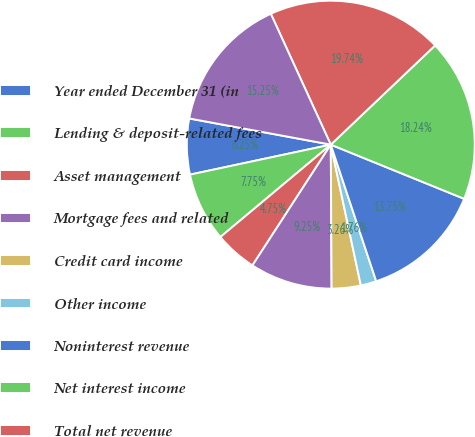Convert chart to OTSL. <chart><loc_0><loc_0><loc_500><loc_500><pie_chart><fcel>Year ended December 31 (in<fcel>Lending & deposit-related fees<fcel>Asset management<fcel>Mortgage fees and related<fcel>Credit card income<fcel>Other income<fcel>Noninterest revenue<fcel>Net interest income<fcel>Total net revenue<fcel>Provision for credit losses<nl><fcel>6.25%<fcel>7.75%<fcel>4.75%<fcel>9.25%<fcel>3.26%<fcel>1.76%<fcel>13.75%<fcel>18.24%<fcel>19.74%<fcel>15.25%<nl></chart> 